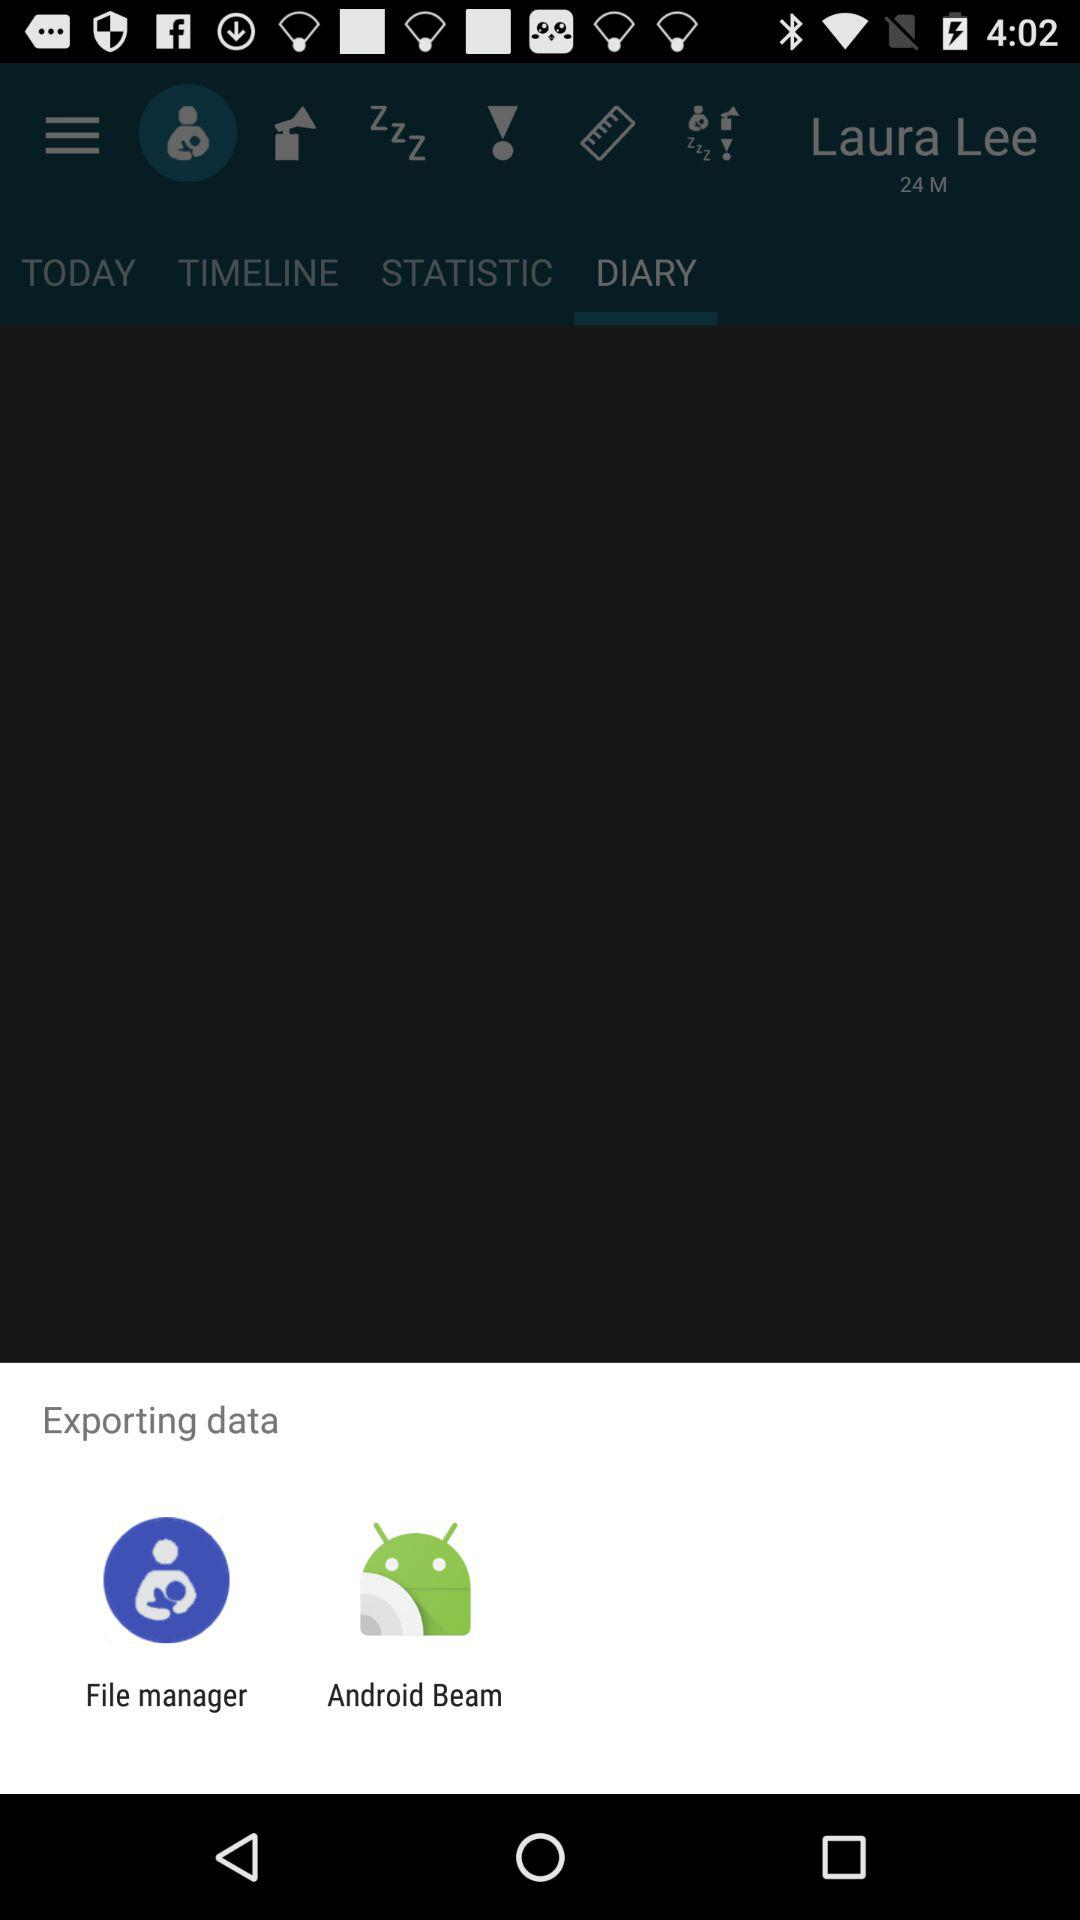What is the user name? The user name is Laura Lee. 